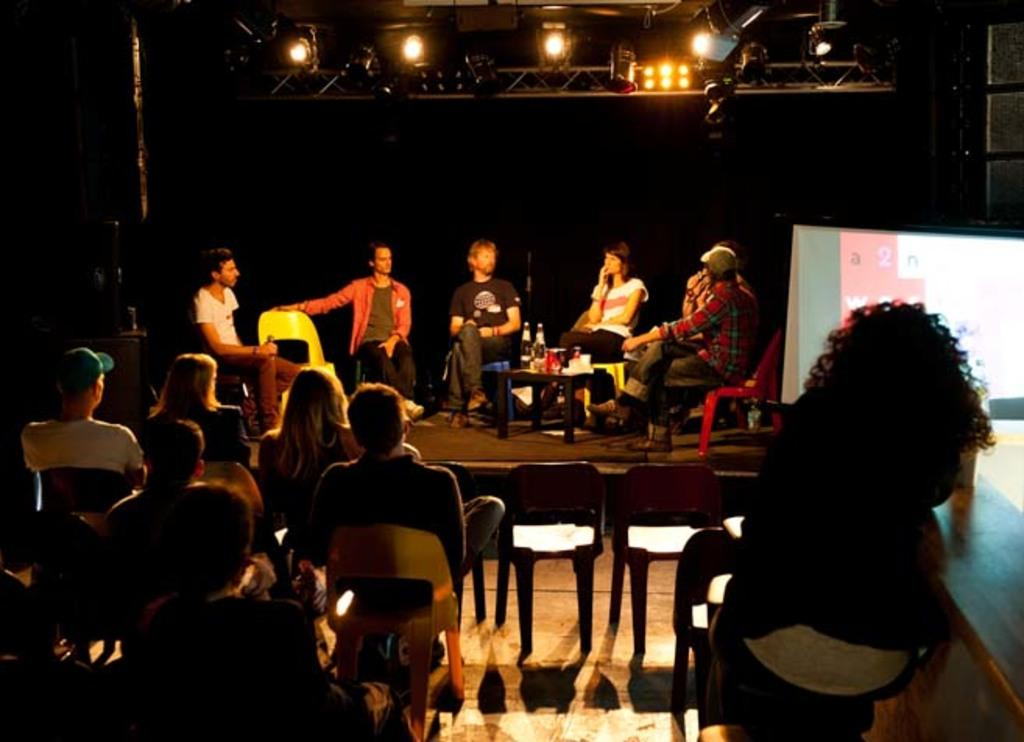Who or what can be seen in the image? There are people in the image. What furniture is present in the image? There are chairs in the image. Can you describe any other objects in the image? There are other objects in the image, but their specific details are not mentioned in the provided facts. What can be seen in the background of the image? In the background of the image, there are people, chairs, bottles, a table, lights, and other objects. What type of loaf is being baked in the field in the image? There is no mention of a loaf or a field in the image; it features people and chairs with other objects and background details. 